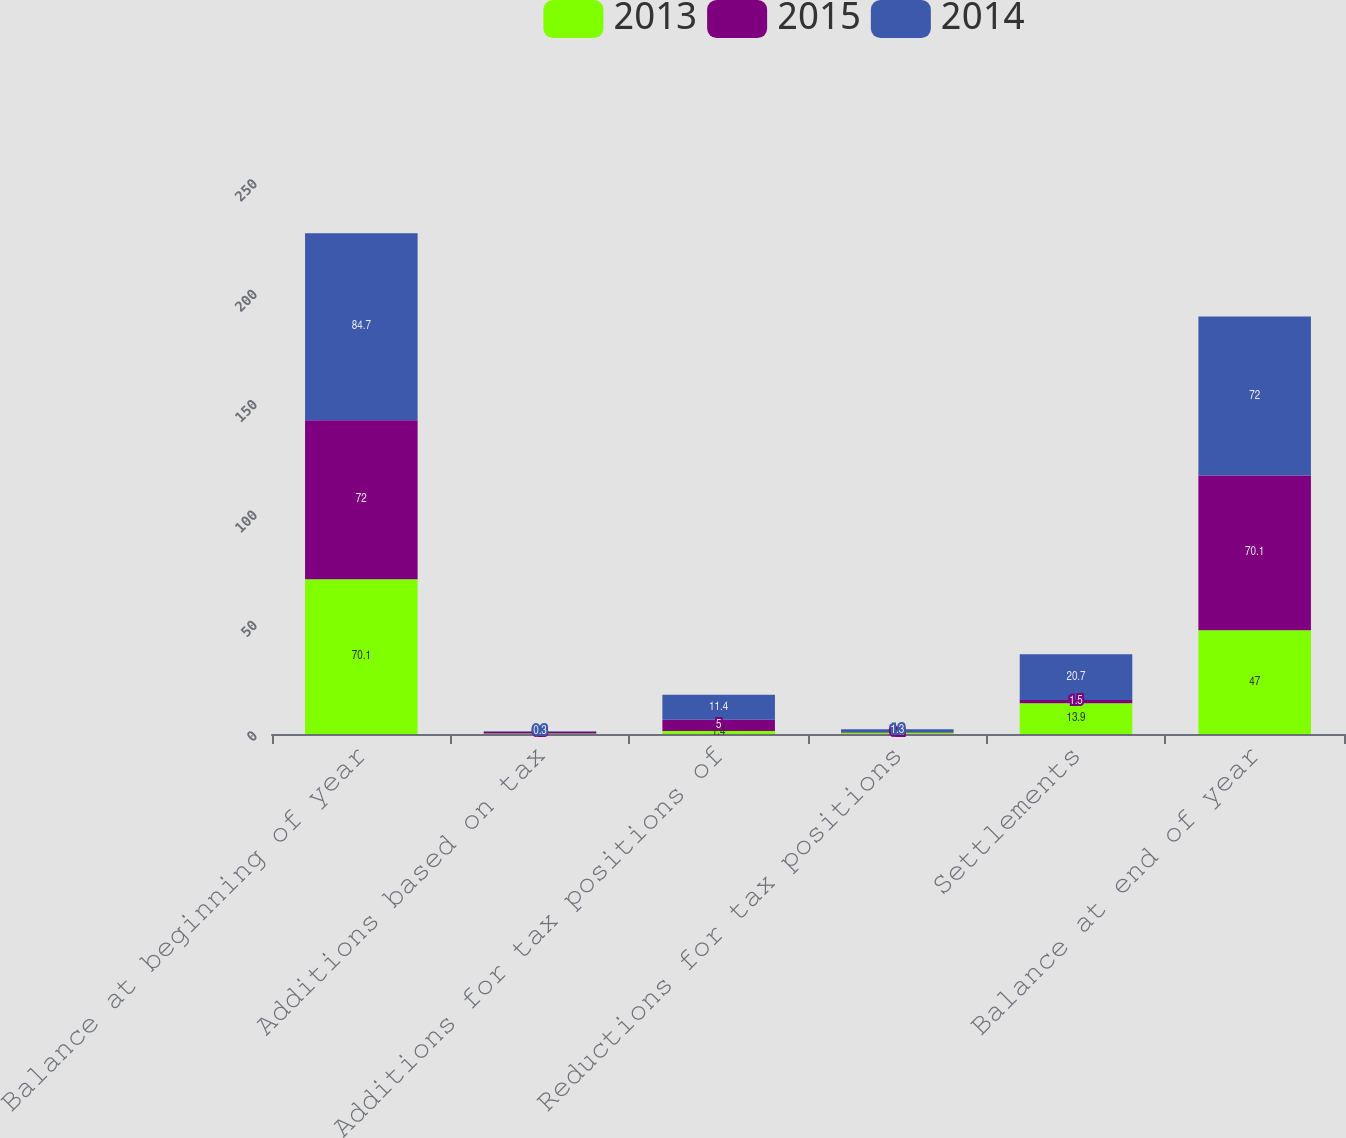Convert chart. <chart><loc_0><loc_0><loc_500><loc_500><stacked_bar_chart><ecel><fcel>Balance at beginning of year<fcel>Additions based on tax<fcel>Additions for tax positions of<fcel>Reductions for tax positions<fcel>Settlements<fcel>Balance at end of year<nl><fcel>2013<fcel>70.1<fcel>0.2<fcel>1.4<fcel>0.6<fcel>13.9<fcel>47<nl><fcel>2015<fcel>72<fcel>0.8<fcel>5<fcel>0.2<fcel>1.5<fcel>70.1<nl><fcel>2014<fcel>84.7<fcel>0.3<fcel>11.4<fcel>1.3<fcel>20.7<fcel>72<nl></chart> 